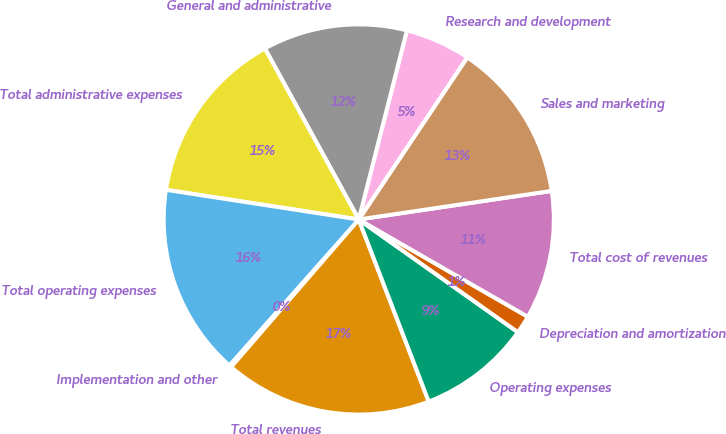Convert chart. <chart><loc_0><loc_0><loc_500><loc_500><pie_chart><fcel>Implementation and other<fcel>Total revenues<fcel>Operating expenses<fcel>Depreciation and amortization<fcel>Total cost of revenues<fcel>Sales and marketing<fcel>Research and development<fcel>General and administrative<fcel>Total administrative expenses<fcel>Total operating expenses<nl><fcel>0.19%<fcel>17.19%<fcel>9.35%<fcel>1.5%<fcel>10.65%<fcel>13.27%<fcel>5.42%<fcel>11.96%<fcel>14.58%<fcel>15.89%<nl></chart> 